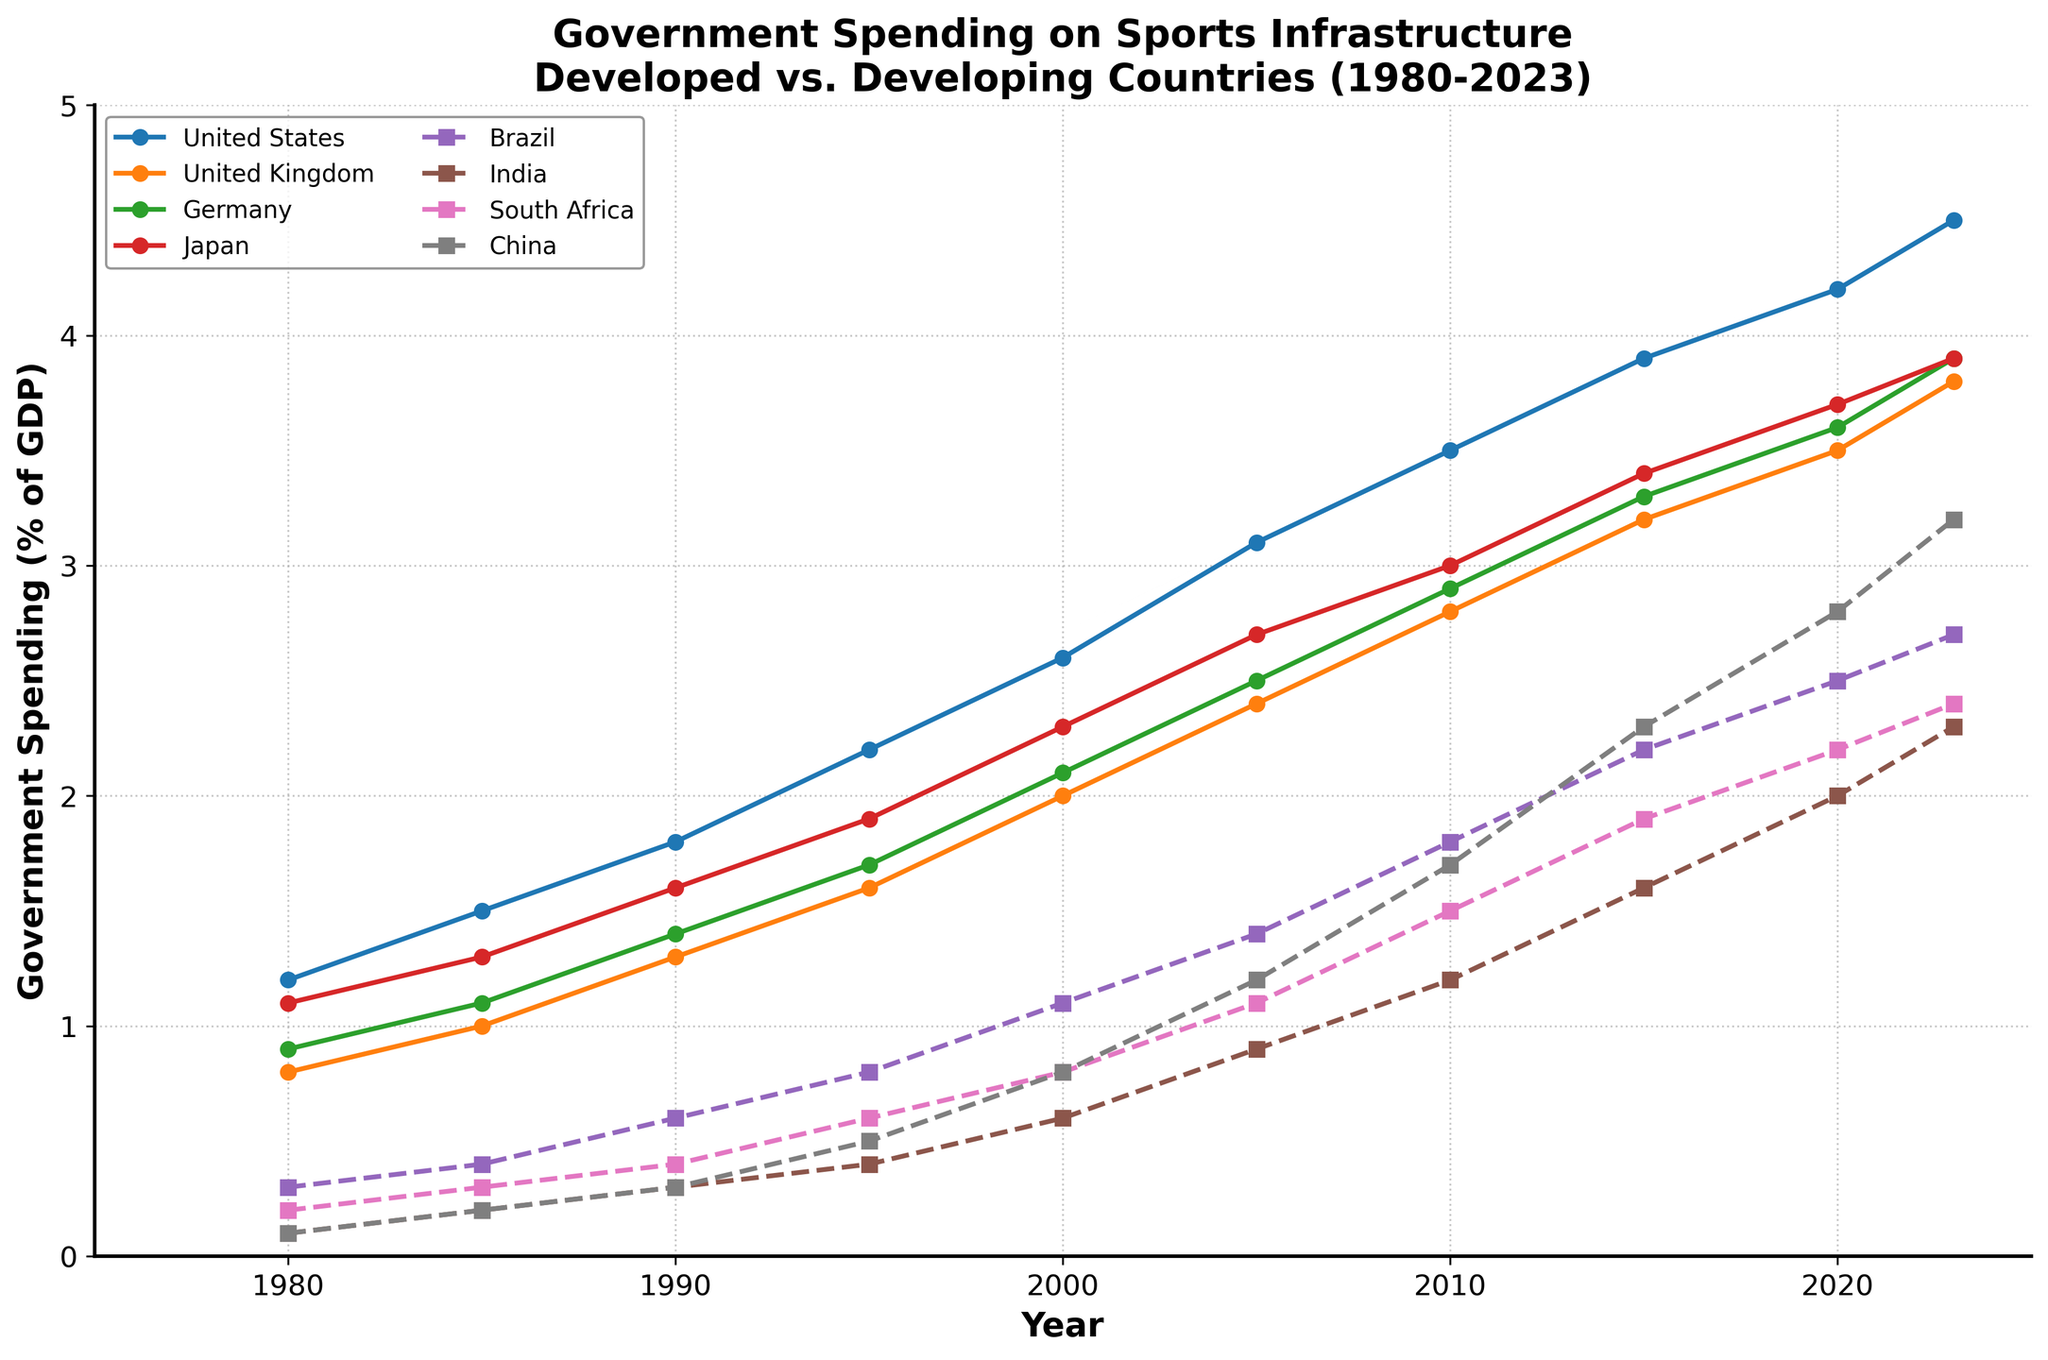What's the difference in government spending on sports infrastructure between the United States and China in 2023? To find the difference, subtract China's value from the United States' value for the year 2023: 4.5 (United States) - 3.2 (China) = 1.3
Answer: 1.3 Which developed country had the highest increase in government spending on sports infrastructure from 1980 to 2023? Calculate the increase for each developed country by subtracting the 1980 value from the 2023 value. The United States: 4.5 - 1.2 = 3.3, United Kingdom: 3.8 - 0.8 = 3.0, Germany: 3.9 - 0.9 = 3.0, Japan: 3.9 - 1.1 = 2.8. The United States had the highest increase, 3.3.
Answer: The United States How does the spending of developing countries in 2023 compare to that of developed countries in 1980? The spending in 2023 for developing countries is Brazil: 2.7, India: 2.3, South Africa: 2.4, China: 3.2. In 1980, the developed countries had the following spending: United States: 1.2, United Kingdom: 0.8, Germany: 0.9, Japan: 1.1. All developing countries in 2023 spent more than the developed countries did in 1980.
Answer: Higher By how much did Japan's government spending on sports infrastructure change from 1985 to 2000? Subtract Japan's spending in 1985 from its spending in 2000: 2.3 - 1.3 = 1.0
Answer: 1.0 What is the average yearly spending on sports infrastructure for developing countries in 2010? Sum the 2010 values for Brazil, India, South Africa, and China and divide by 4. (1.8 + 1.2 + 1.5 + 1.7) / 4 = 6.2 / 4 = 1.55
Answer: 1.55 After which year did China's spending on sports infrastructure surpass 2% of its GDP? Observe the trend line for China and identify the year after which its spending exceeds 2%. This happens after 2015 when the spending is more than 2%.
Answer: 2015 Between which two consecutive years did Brazil see the largest increase in government spending on sports infrastructure? Calculate the increases year-by-year and find the largest: 1985-1980: 0.4-0.3=0.1, 1990-1985: 0.6-0.4=0.2, 1995-1990: 0.8-0.6=0.2, 2000-1995: 1.1-0.8=0.3, 2005-2000: 1.4-1.1=0.3, 2010-2005: 1.8-1.4=0.4, 2015-2010: 2.2-1.8=0.4, 2020-2015: 2.5-2.2=0.3, 2023-2020: 2.7-2.5=0.2. The largest increase is 2010-2005 and 2015-2010 with an increase of 0.4 each.
Answer: 2010 to 2015 What trend do you observe for India's government spending on sports infrastructure from 1980 to 2023? India's spending shows a continuous increase across the years. The spending starts at 0.1 in 1980 and reaches 2.3 in 2023, which indicates a gradual and steady upward trend.
Answer: Continuous increase 